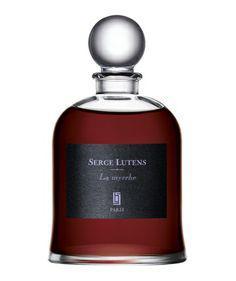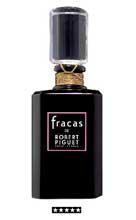The first image is the image on the left, the second image is the image on the right. Analyze the images presented: Is the assertion "There is one more container in the image on the left than there is in the image on the right." valid? Answer yes or no. No. The first image is the image on the left, the second image is the image on the right. For the images shown, is this caption "An image shows a trio of fragance bottles of the same size and shape, displayed in a triangular formation." true? Answer yes or no. No. 